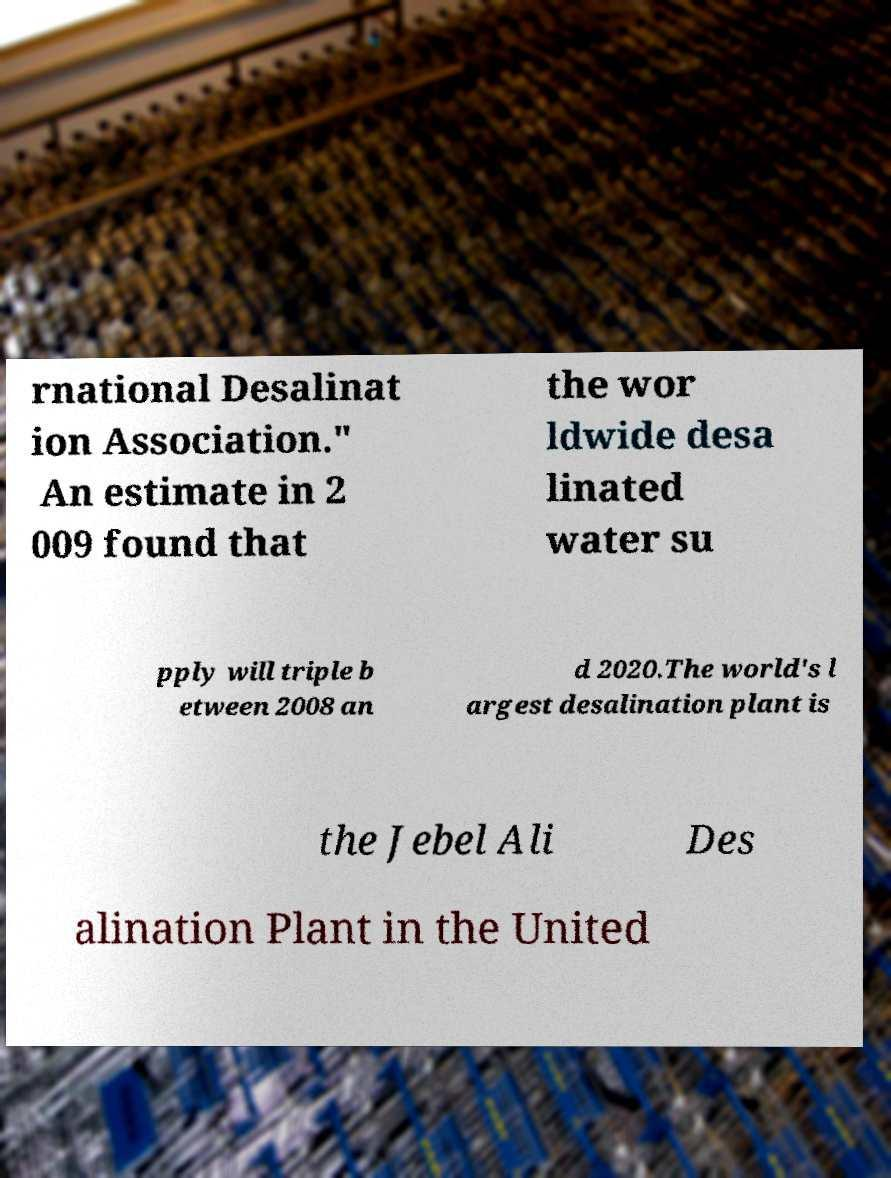I need the written content from this picture converted into text. Can you do that? rnational Desalinat ion Association." An estimate in 2 009 found that the wor ldwide desa linated water su pply will triple b etween 2008 an d 2020.The world's l argest desalination plant is the Jebel Ali Des alination Plant in the United 